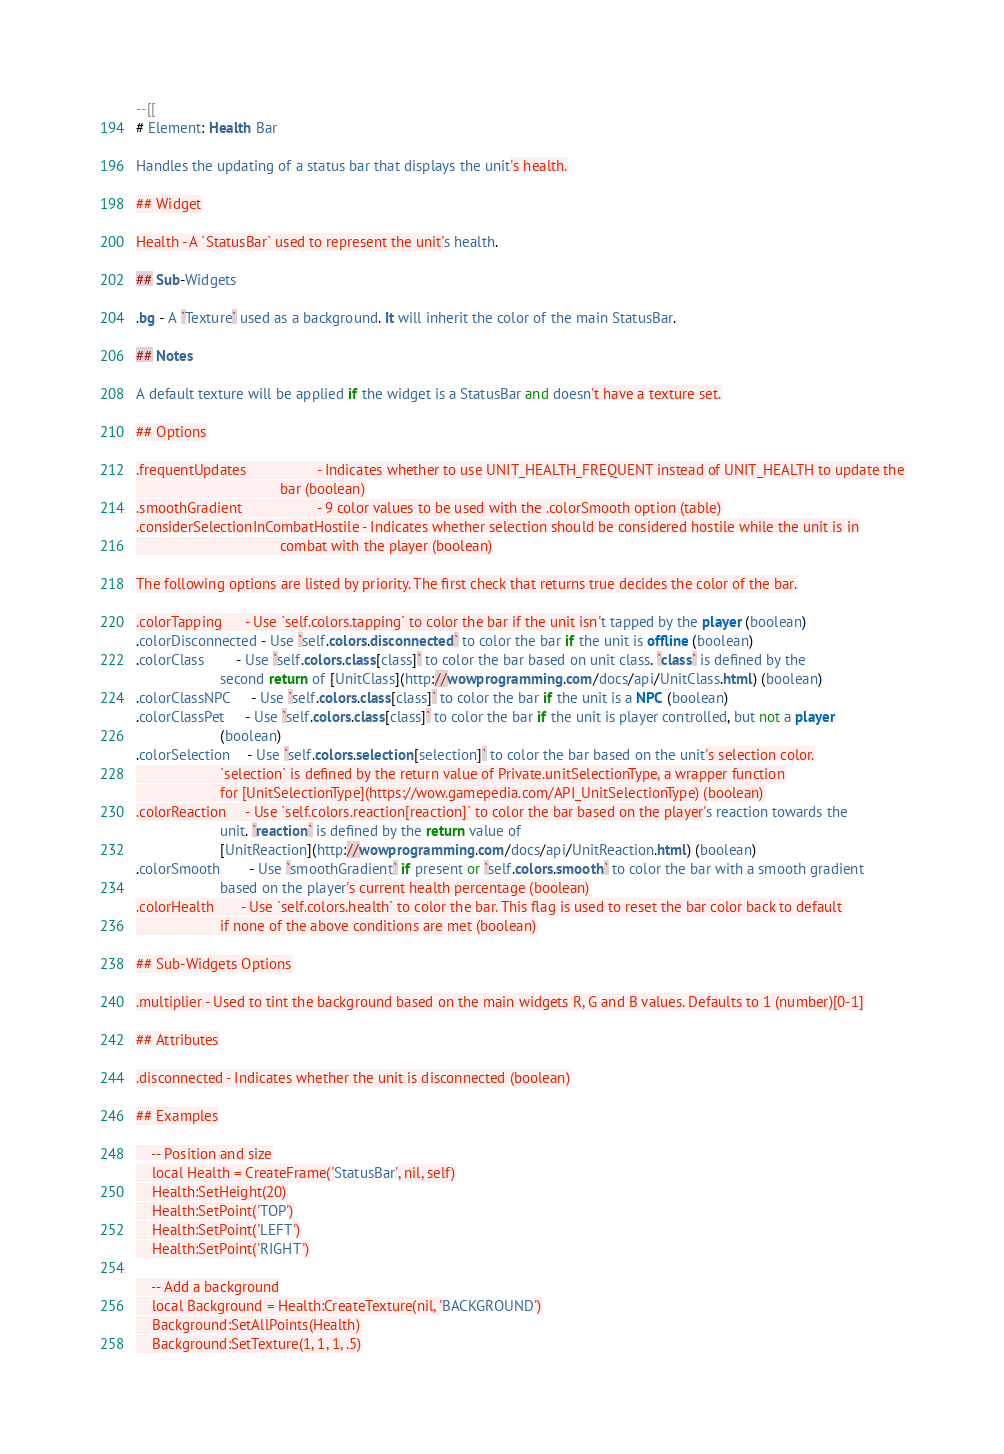Convert code to text. <code><loc_0><loc_0><loc_500><loc_500><_Lua_>--[[
# Element: Health Bar

Handles the updating of a status bar that displays the unit's health.

## Widget

Health - A `StatusBar` used to represent the unit's health.

## Sub-Widgets

.bg - A `Texture` used as a background. It will inherit the color of the main StatusBar.

## Notes

A default texture will be applied if the widget is a StatusBar and doesn't have a texture set.

## Options

.frequentUpdates                  - Indicates whether to use UNIT_HEALTH_FREQUENT instead of UNIT_HEALTH to update the
                                    bar (boolean)
.smoothGradient                   - 9 color values to be used with the .colorSmooth option (table)
.considerSelectionInCombatHostile - Indicates whether selection should be considered hostile while the unit is in
                                    combat with the player (boolean)

The following options are listed by priority. The first check that returns true decides the color of the bar.

.colorTapping      - Use `self.colors.tapping` to color the bar if the unit isn't tapped by the player (boolean)
.colorDisconnected - Use `self.colors.disconnected` to color the bar if the unit is offline (boolean)
.colorClass        - Use `self.colors.class[class]` to color the bar based on unit class. `class` is defined by the
                     second return of [UnitClass](http://wowprogramming.com/docs/api/UnitClass.html) (boolean)
.colorClassNPC     - Use `self.colors.class[class]` to color the bar if the unit is a NPC (boolean)
.colorClassPet     - Use `self.colors.class[class]` to color the bar if the unit is player controlled, but not a player
                     (boolean)
.colorSelection    - Use `self.colors.selection[selection]` to color the bar based on the unit's selection color.
                     `selection` is defined by the return value of Private.unitSelectionType, a wrapper function
                     for [UnitSelectionType](https://wow.gamepedia.com/API_UnitSelectionType) (boolean)
.colorReaction     - Use `self.colors.reaction[reaction]` to color the bar based on the player's reaction towards the
                     unit. `reaction` is defined by the return value of
                     [UnitReaction](http://wowprogramming.com/docs/api/UnitReaction.html) (boolean)
.colorSmooth       - Use `smoothGradient` if present or `self.colors.smooth` to color the bar with a smooth gradient
                     based on the player's current health percentage (boolean)
.colorHealth       - Use `self.colors.health` to color the bar. This flag is used to reset the bar color back to default
                     if none of the above conditions are met (boolean)

## Sub-Widgets Options

.multiplier - Used to tint the background based on the main widgets R, G and B values. Defaults to 1 (number)[0-1]

## Attributes

.disconnected - Indicates whether the unit is disconnected (boolean)

## Examples

    -- Position and size
    local Health = CreateFrame('StatusBar', nil, self)
    Health:SetHeight(20)
    Health:SetPoint('TOP')
    Health:SetPoint('LEFT')
    Health:SetPoint('RIGHT')

    -- Add a background
    local Background = Health:CreateTexture(nil, 'BACKGROUND')
    Background:SetAllPoints(Health)
    Background:SetTexture(1, 1, 1, .5)
</code> 